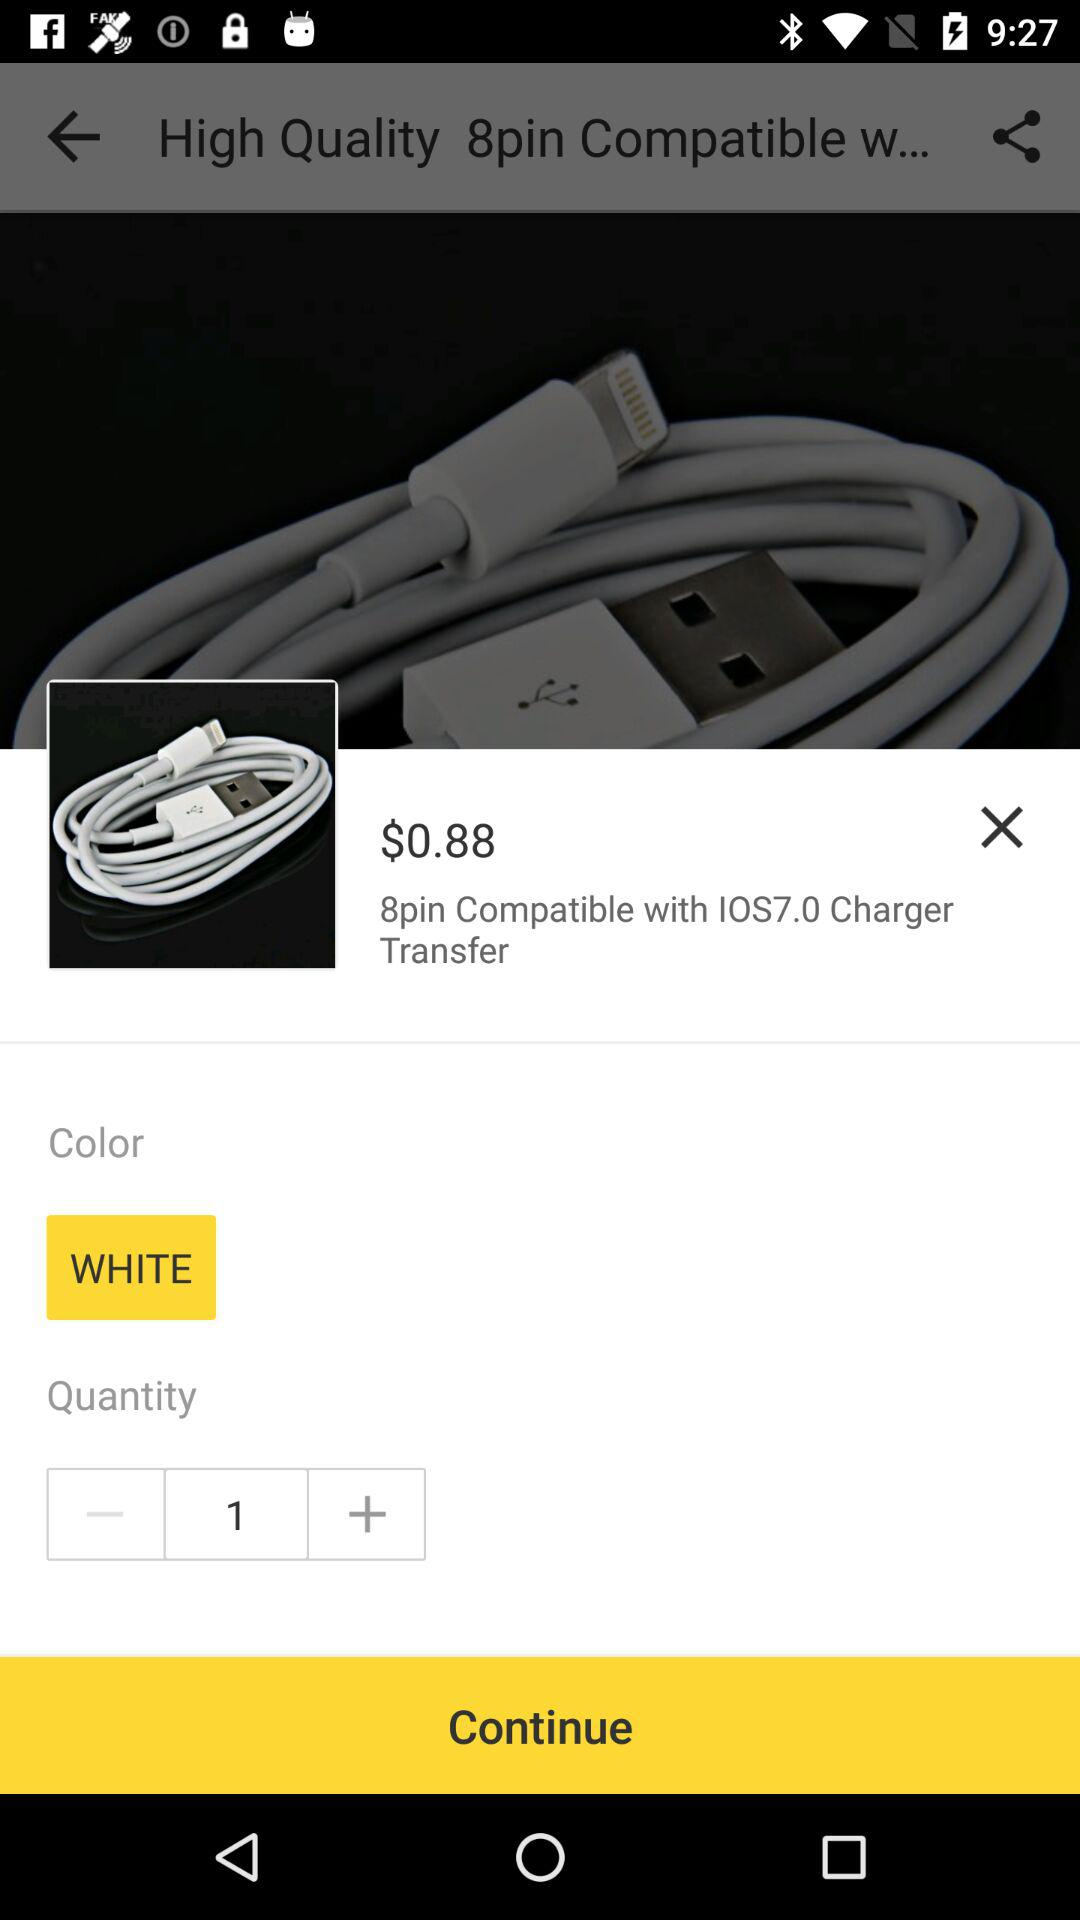What is the price of the item?
Answer the question using a single word or phrase. $0.88 